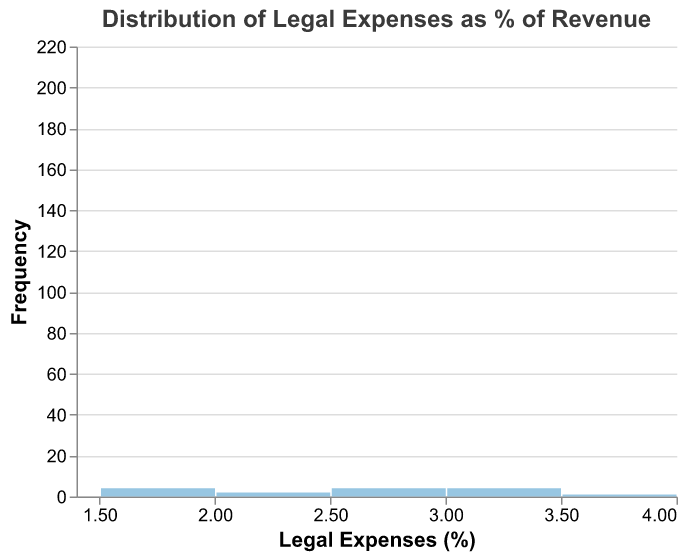What is the title of the plot? The title is usually displayed at the top of the chart and summarizes the main topic of the visualization.
Answer: Distribution of Legal Expenses as % of Revenue How many companies have legal expenses between 2% and 3% of their revenue? To find this, count the number of bars that fall between the 2% and 3% range on the x-axis and sum their frequencies.
Answer: 8 Which company has the highest legal expenses as a percentage of revenue? Identify the highest point on the x-axis and find the associated company.
Answer: Theta Innovations What is the most common range of legal expenses percentages among these companies? Look for the bar with the highest frequency along the x-axis.
Answer: 2% to 2.5% How does the number of companies with legal expenses between 1.5% - 2% compare to those with 3.0% - 3.5%? Count the bars within each range and compare their heights (frequencies).
Answer: 3 for 1.5%-2%, 3 for 3.0%-3.5% What is the median value of legal expenses as a percentage of revenue? Median is the middle value in an ordered list of percentages; list the values in numeric order and find the middle one.
Answer: 2.6% What is the frequency of companies that have legal expenses less than 2%? Add the bar counts that represent percentages below 2% on the x-axis.
Answer: 4 Compare the frequency of companies with legal expenses between 1.5% - 2.5% to those with legal expenses between 2.5% - 3.5%. Count the number of companies in each range and then compare the sums.
Answer: 7 for 1.5%-2.5%, 6 for 2.5%-3.5% Which company has the lowest legal expenses as a percentage of revenue? Identify the lowest point on the x-axis and find the associated company.
Answer: Delta Solutions Are there more companies with legal expenses above or below 2.5% of their revenue? Count the bars above and below 2.5% on the x-axis and compare.
Answer: More below 